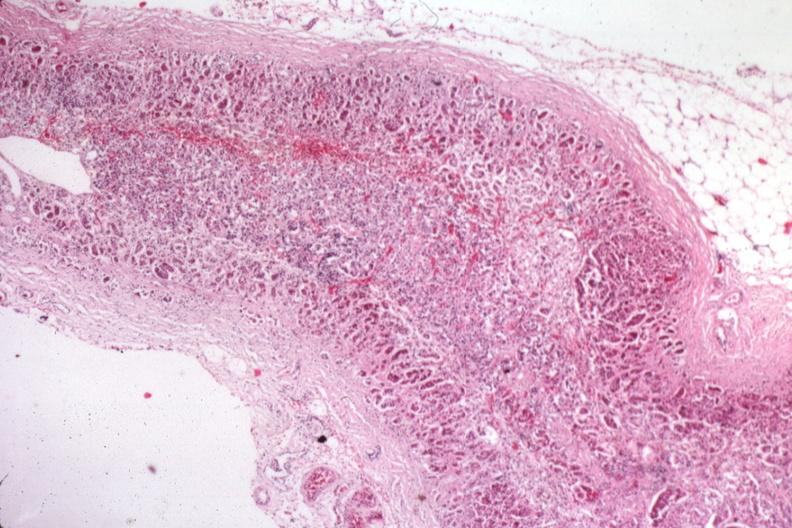what is present?
Answer the question using a single word or phrase. Endocrine 